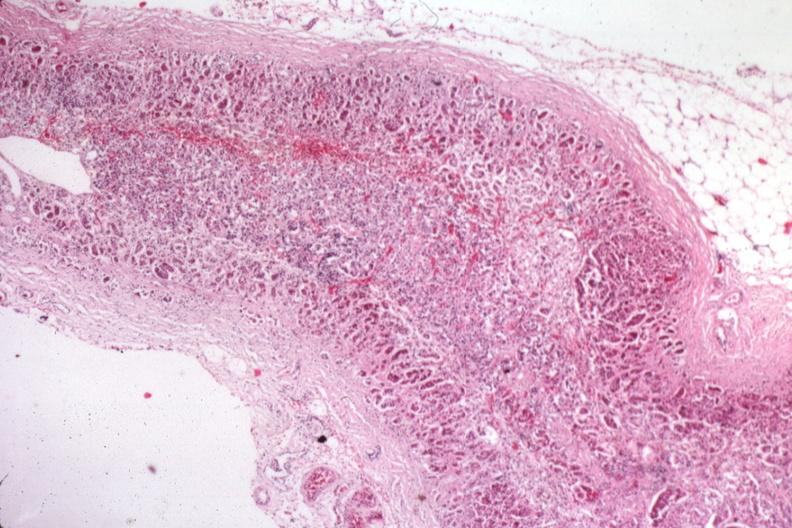what is present?
Answer the question using a single word or phrase. Endocrine 